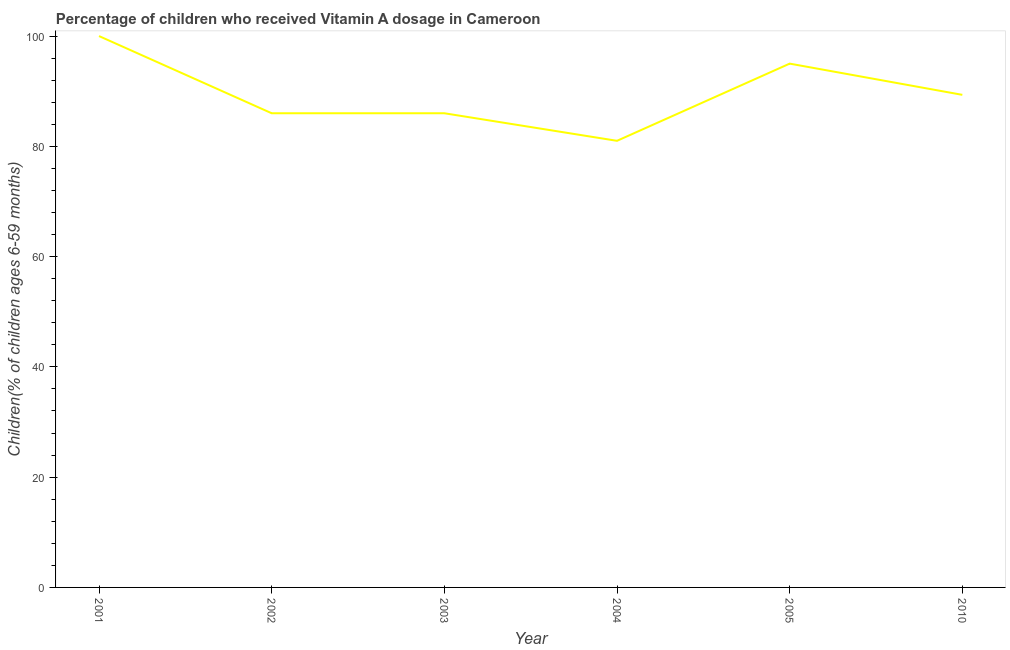What is the vitamin a supplementation coverage rate in 2001?
Offer a terse response. 100. Across all years, what is the maximum vitamin a supplementation coverage rate?
Your response must be concise. 100. Across all years, what is the minimum vitamin a supplementation coverage rate?
Offer a very short reply. 81. In which year was the vitamin a supplementation coverage rate maximum?
Provide a short and direct response. 2001. What is the sum of the vitamin a supplementation coverage rate?
Your answer should be compact. 537.34. What is the difference between the vitamin a supplementation coverage rate in 2001 and 2010?
Make the answer very short. 10.66. What is the average vitamin a supplementation coverage rate per year?
Keep it short and to the point. 89.56. What is the median vitamin a supplementation coverage rate?
Offer a terse response. 87.67. Do a majority of the years between 2001 and 2005 (inclusive) have vitamin a supplementation coverage rate greater than 40 %?
Give a very brief answer. Yes. What is the ratio of the vitamin a supplementation coverage rate in 2002 to that in 2005?
Provide a short and direct response. 0.91. Is the difference between the vitamin a supplementation coverage rate in 2003 and 2004 greater than the difference between any two years?
Your response must be concise. No. What is the difference between the highest and the second highest vitamin a supplementation coverage rate?
Your answer should be very brief. 5. Is the sum of the vitamin a supplementation coverage rate in 2002 and 2005 greater than the maximum vitamin a supplementation coverage rate across all years?
Offer a very short reply. Yes. Does the vitamin a supplementation coverage rate monotonically increase over the years?
Your response must be concise. No. How many lines are there?
Give a very brief answer. 1. What is the difference between two consecutive major ticks on the Y-axis?
Offer a very short reply. 20. Are the values on the major ticks of Y-axis written in scientific E-notation?
Provide a short and direct response. No. Does the graph contain any zero values?
Your answer should be very brief. No. Does the graph contain grids?
Your answer should be very brief. No. What is the title of the graph?
Keep it short and to the point. Percentage of children who received Vitamin A dosage in Cameroon. What is the label or title of the X-axis?
Your answer should be compact. Year. What is the label or title of the Y-axis?
Provide a short and direct response. Children(% of children ages 6-59 months). What is the Children(% of children ages 6-59 months) in 2001?
Provide a short and direct response. 100. What is the Children(% of children ages 6-59 months) of 2002?
Ensure brevity in your answer.  86. What is the Children(% of children ages 6-59 months) in 2003?
Your response must be concise. 86. What is the Children(% of children ages 6-59 months) in 2010?
Keep it short and to the point. 89.34. What is the difference between the Children(% of children ages 6-59 months) in 2001 and 2002?
Ensure brevity in your answer.  14. What is the difference between the Children(% of children ages 6-59 months) in 2001 and 2004?
Make the answer very short. 19. What is the difference between the Children(% of children ages 6-59 months) in 2001 and 2005?
Make the answer very short. 5. What is the difference between the Children(% of children ages 6-59 months) in 2001 and 2010?
Your response must be concise. 10.66. What is the difference between the Children(% of children ages 6-59 months) in 2002 and 2004?
Provide a succinct answer. 5. What is the difference between the Children(% of children ages 6-59 months) in 2002 and 2010?
Your response must be concise. -3.34. What is the difference between the Children(% of children ages 6-59 months) in 2003 and 2010?
Keep it short and to the point. -3.34. What is the difference between the Children(% of children ages 6-59 months) in 2004 and 2010?
Offer a terse response. -8.34. What is the difference between the Children(% of children ages 6-59 months) in 2005 and 2010?
Offer a terse response. 5.66. What is the ratio of the Children(% of children ages 6-59 months) in 2001 to that in 2002?
Your answer should be very brief. 1.16. What is the ratio of the Children(% of children ages 6-59 months) in 2001 to that in 2003?
Give a very brief answer. 1.16. What is the ratio of the Children(% of children ages 6-59 months) in 2001 to that in 2004?
Provide a short and direct response. 1.24. What is the ratio of the Children(% of children ages 6-59 months) in 2001 to that in 2005?
Make the answer very short. 1.05. What is the ratio of the Children(% of children ages 6-59 months) in 2001 to that in 2010?
Your answer should be compact. 1.12. What is the ratio of the Children(% of children ages 6-59 months) in 2002 to that in 2003?
Offer a terse response. 1. What is the ratio of the Children(% of children ages 6-59 months) in 2002 to that in 2004?
Give a very brief answer. 1.06. What is the ratio of the Children(% of children ages 6-59 months) in 2002 to that in 2005?
Your response must be concise. 0.91. What is the ratio of the Children(% of children ages 6-59 months) in 2003 to that in 2004?
Offer a very short reply. 1.06. What is the ratio of the Children(% of children ages 6-59 months) in 2003 to that in 2005?
Offer a terse response. 0.91. What is the ratio of the Children(% of children ages 6-59 months) in 2003 to that in 2010?
Give a very brief answer. 0.96. What is the ratio of the Children(% of children ages 6-59 months) in 2004 to that in 2005?
Ensure brevity in your answer.  0.85. What is the ratio of the Children(% of children ages 6-59 months) in 2004 to that in 2010?
Your response must be concise. 0.91. What is the ratio of the Children(% of children ages 6-59 months) in 2005 to that in 2010?
Offer a very short reply. 1.06. 